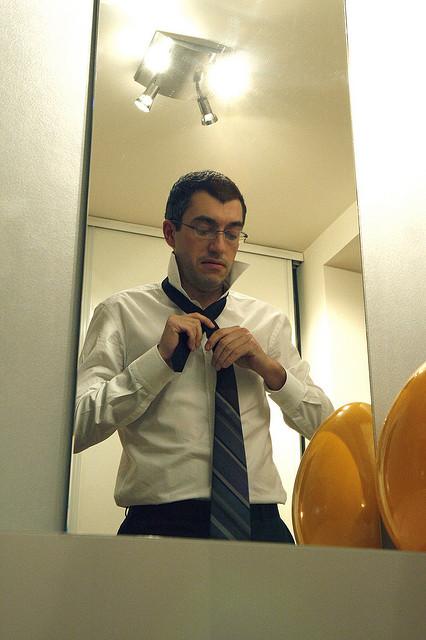Is the light on or off?
Short answer required. On. Is this man about to go work in a coal mine?
Quick response, please. No. Is the man getting dressed?
Be succinct. Yes. 